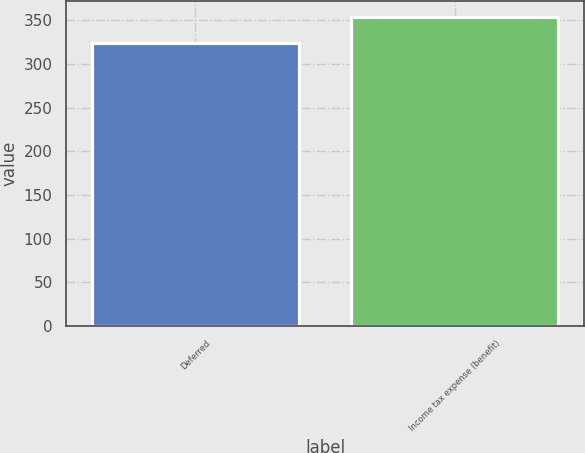<chart> <loc_0><loc_0><loc_500><loc_500><bar_chart><fcel>Deferred<fcel>Income tax expense (benefit)<nl><fcel>324<fcel>354<nl></chart> 